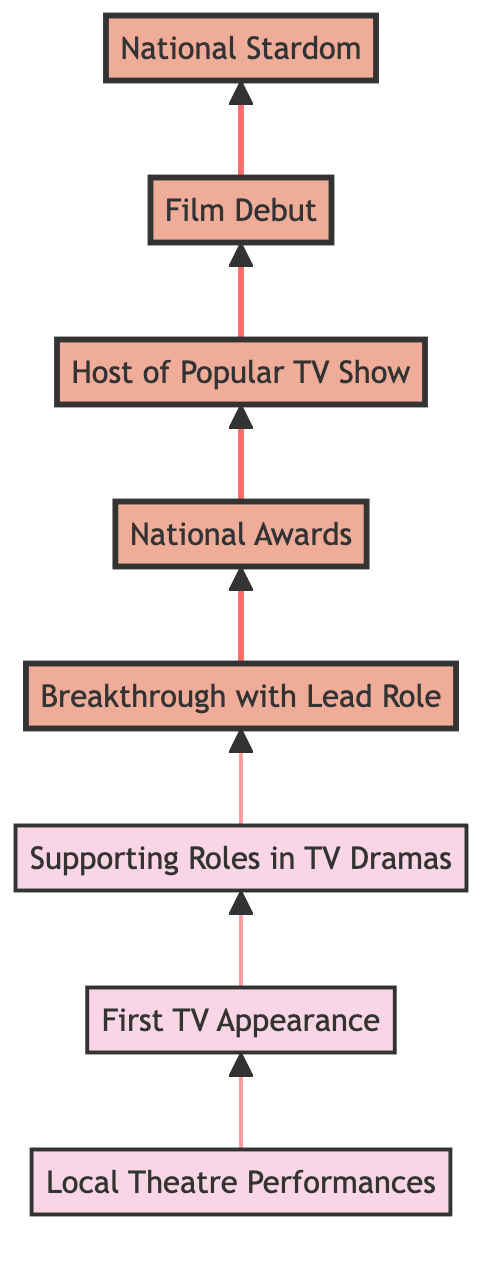What is the bottommost stage in Toya's career progression? The bottommost stage in the flow chart is "Local Theatre Performances," indicating the starting point of Toya's career.
Answer: Local Theatre Performances How many stages are there in Toya’s career progression? By counting each distinct career stage in the diagram, we find there are a total of eight defined stages from local theatre to national stardom.
Answer: Eight Which stage follows her "First TV Appearance"? The "Supporting Roles in TV Dramas" stage directly follows the "First TV Appearance" in the upward flow of her career progression.
Answer: Supporting Roles in TV Dramas What major achievement did Toya receive after the "Breakthrough with Lead Role"? Following the "Breakthrough with Lead Role," Toya received "National Awards" as recognition for her impactful performances.
Answer: National Awards What kind of show did Toya host as part of her career expansion? As part of her career expansion, Toya hosted a "Popular TV Show," specifically titled "Ajker Ononna," where she interviewed notable personalities.
Answer: Popular TV Show At which stage did Toya achieve significant recognition that led to national acclaim? The stage where Toya achieved significant recognition that led to national acclaim is "National Stardom," following her hard work and impactful performances in both TV and film.
Answer: National Stardom What was the title of Toya's film debut? Toya's film debut is titled "Bela Obela," marking her entry into the film industry after her success in television.
Answer: Bela Obela What critical accomplishment is linked to Toya's performances after receiving national awards? After receiving national awards, Toya's critical accomplishment is becoming a "household name in Bangladesh," signifying her widespread recognition and popularity.
Answer: Household name in Bangladesh Which stage represents Toya's transition from acting to hosting? The transition from acting to hosting is represented by the "Host of Popular TV Show" stage, highlighting her diversification into different roles in the entertainment industry.
Answer: Host of Popular TV Show 